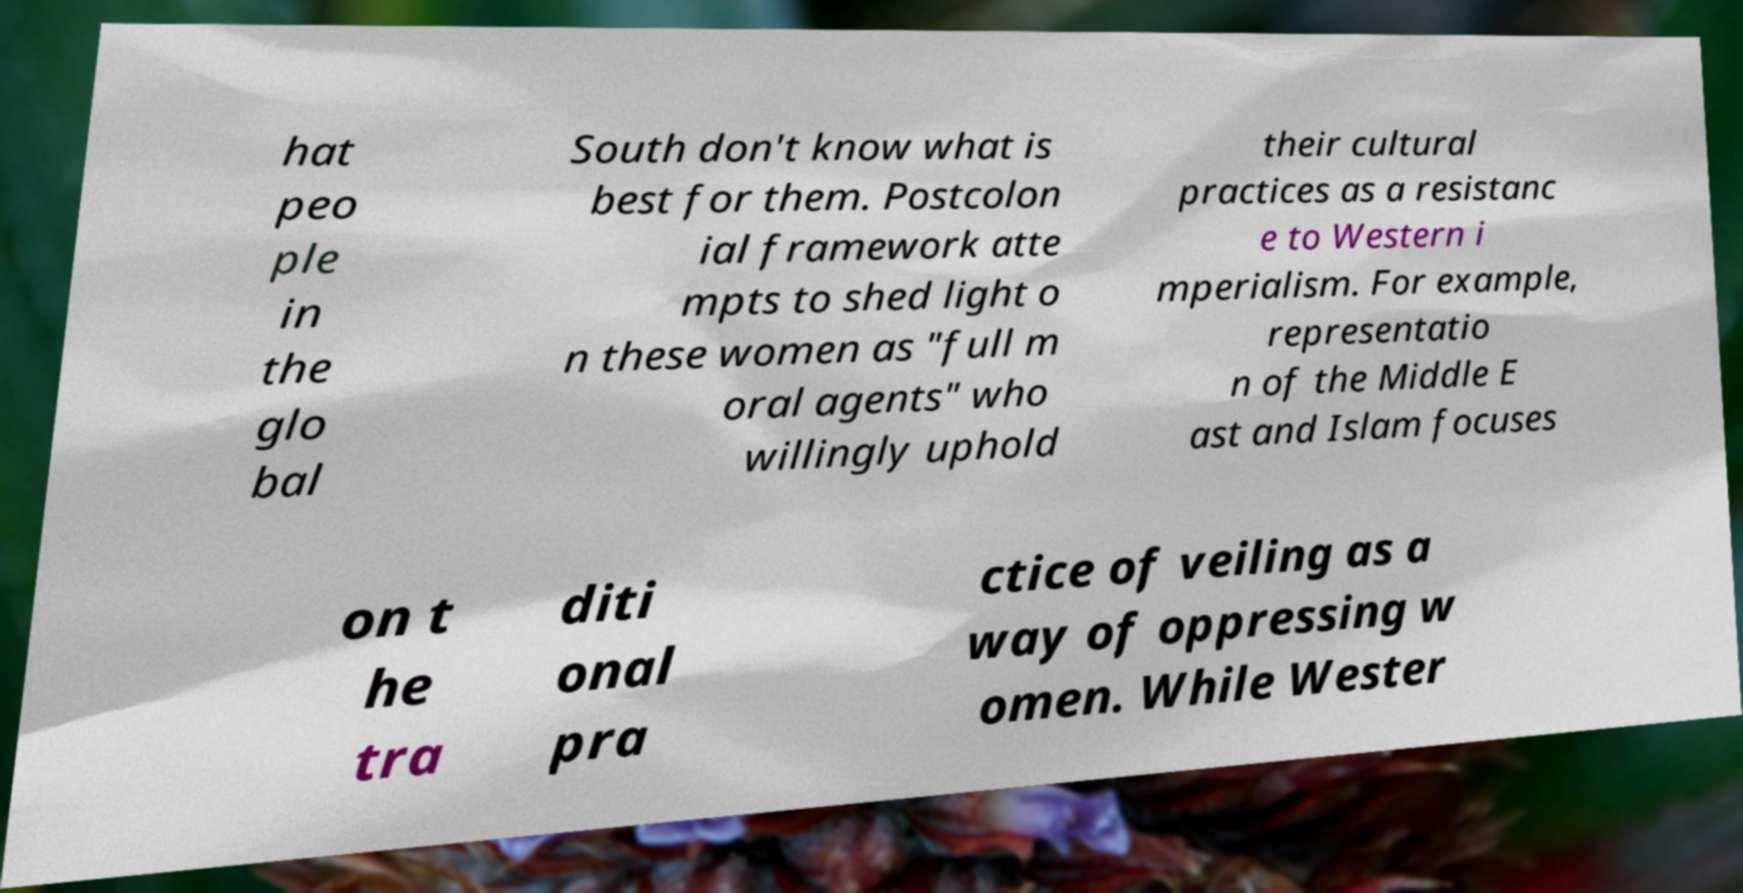I need the written content from this picture converted into text. Can you do that? hat peo ple in the glo bal South don't know what is best for them. Postcolon ial framework atte mpts to shed light o n these women as "full m oral agents" who willingly uphold their cultural practices as a resistanc e to Western i mperialism. For example, representatio n of the Middle E ast and Islam focuses on t he tra diti onal pra ctice of veiling as a way of oppressing w omen. While Wester 